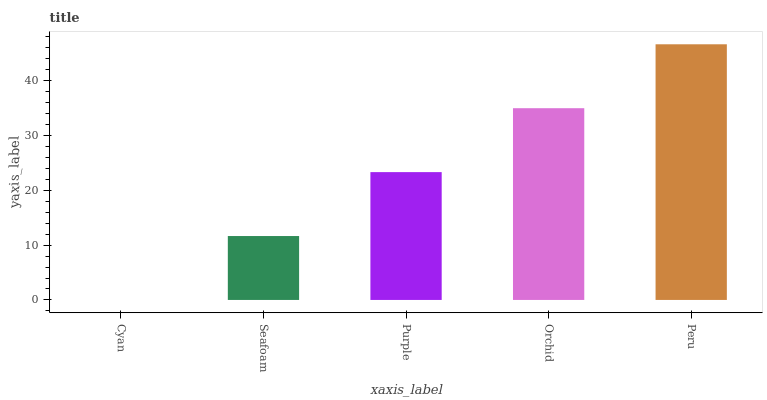Is Seafoam the minimum?
Answer yes or no. No. Is Seafoam the maximum?
Answer yes or no. No. Is Seafoam greater than Cyan?
Answer yes or no. Yes. Is Cyan less than Seafoam?
Answer yes or no. Yes. Is Cyan greater than Seafoam?
Answer yes or no. No. Is Seafoam less than Cyan?
Answer yes or no. No. Is Purple the high median?
Answer yes or no. Yes. Is Purple the low median?
Answer yes or no. Yes. Is Seafoam the high median?
Answer yes or no. No. Is Orchid the low median?
Answer yes or no. No. 